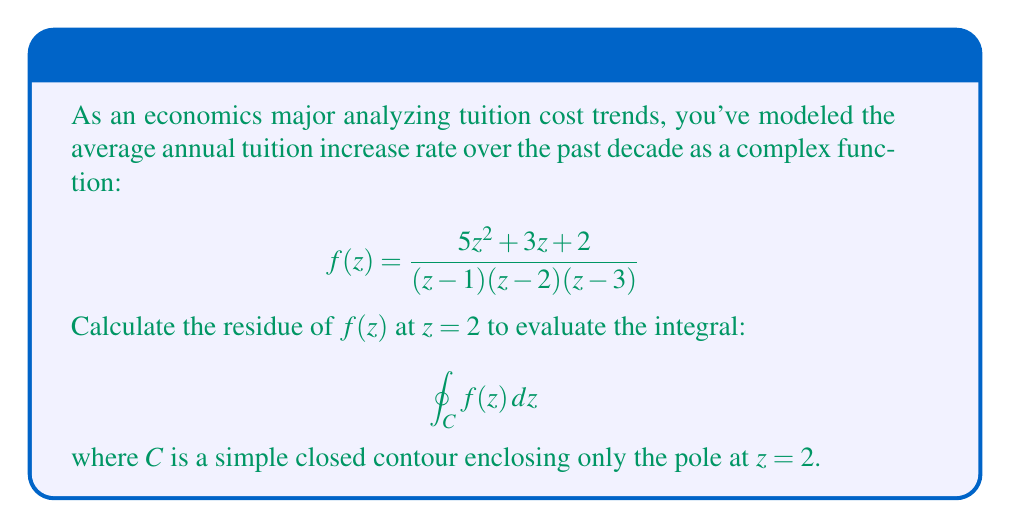Show me your answer to this math problem. To calculate the residue at $z=2$, we'll use the formula for a simple pole:

$$\text{Res}(f,2) = \lim_{z \to 2} (z-2)f(z)$$

1) First, factor out $(z-2)$ from the denominator:
   $$f(z) = \frac{5z^2 + 3z + 2}{(z-1)(z-3)} \cdot \frac{1}{z-2}$$

2) Now, we can calculate the limit:
   $$\text{Res}(f,2) = \lim_{z \to 2} \frac{5z^2 + 3z + 2}{(z-1)(z-3)}$$

3) Evaluate the limit by substituting $z=2$:
   $$\text{Res}(f,2) = \frac{5(2)^2 + 3(2) + 2}{(2-1)(2-3)} = \frac{20 + 6 + 2}{1(-1)} = -28$$

4) By the Residue Theorem, we know that for a simple closed contour $C$ enclosing only the pole at $z=2$:
   $$\oint_C f(z) dz = 2\pi i \cdot \text{Res}(f,2)$$

5) Substituting our calculated residue:
   $$\oint_C f(z) dz = 2\pi i \cdot (-28) = -56\pi i$$

This result represents the integral of the tuition increase rate function around the pole at $z=2$, which could be interpreted as a measure of the volatility or impact of this particular trend point on overall tuition costs.
Answer: $-56\pi i$ 